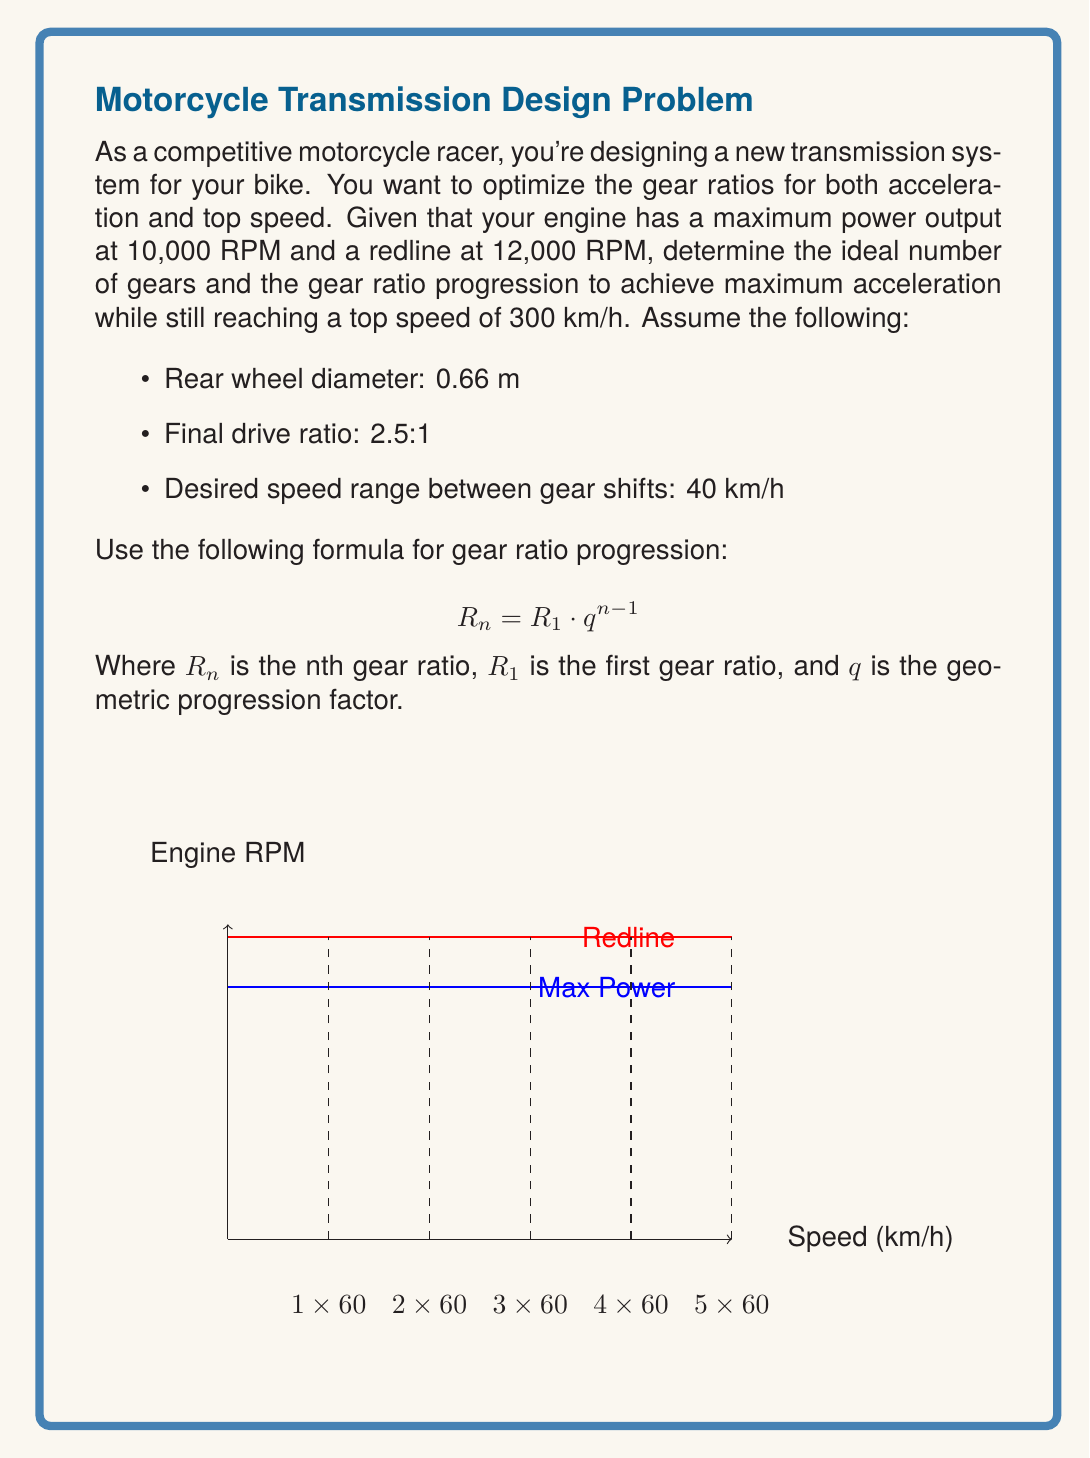Could you help me with this problem? Let's approach this step-by-step:

1) First, we need to calculate the total gear ratio range:
   
   At redline (12,000 RPM) and top speed (300 km/h):
   $$ \text{Total Ratio} = \frac{\text{Engine RPM} \times 2\pi \times \text{Wheel Radius}}{\text{Speed} \times 60 \times \text{Final Drive}} $$
   $$ = \frac{12000 \times 2\pi \times 0.33}{300 \times 1000/3600 \times 2.5} \approx 3.32 $$

2) The first gear ratio should allow the bike to reach 40 km/h at max power (10,000 RPM):
   $$ R_1 = \frac{10000 \times 2\pi \times 0.33}{40 \times 1000/3600 \times 2.5} \approx 20.79 $$

3) Now we can calculate the number of gears needed:
   $$ n = 1 + \frac{\log(3.32/20.79)}{\log(1-40/300)} \approx 6.18 $$
   
   We round this up to 7 gears for better acceleration.

4) Calculate the geometric progression factor:
   $$ q = (3.32/20.79)^{1/6} \approx 0.742 $$

5) Now we can calculate each gear ratio:
   $$ R_1 = 20.79 $$
   $$ R_2 = 20.79 \times 0.742 \approx 15.43 $$
   $$ R_3 = 20.79 \times 0.742^2 \approx 11.45 $$
   $$ R_4 = 20.79 \times 0.742^3 \approx 8.50 $$
   $$ R_5 = 20.79 \times 0.742^4 \approx 6.31 $$
   $$ R_6 = 20.79 \times 0.742^5 \approx 4.68 $$
   $$ R_7 = 20.79 \times 0.742^6 \approx 3.47 $$

These ratios provide optimal acceleration while allowing the bike to reach its top speed in the highest gear.
Answer: 7 gears with ratios: 20.79, 15.43, 11.45, 8.50, 6.31, 4.68, 3.47 